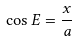<formula> <loc_0><loc_0><loc_500><loc_500>\cos E = \frac { x } { a }</formula> 